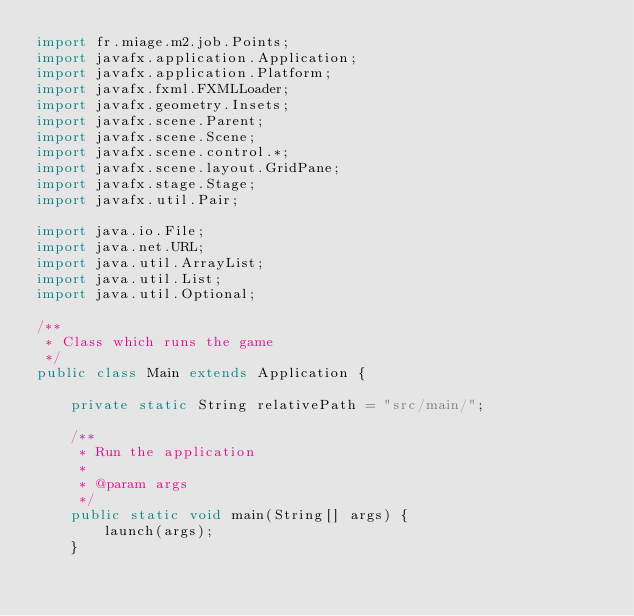<code> <loc_0><loc_0><loc_500><loc_500><_Java_>import fr.miage.m2.job.Points;
import javafx.application.Application;
import javafx.application.Platform;
import javafx.fxml.FXMLLoader;
import javafx.geometry.Insets;
import javafx.scene.Parent;
import javafx.scene.Scene;
import javafx.scene.control.*;
import javafx.scene.layout.GridPane;
import javafx.stage.Stage;
import javafx.util.Pair;

import java.io.File;
import java.net.URL;
import java.util.ArrayList;
import java.util.List;
import java.util.Optional;

/**
 * Class which runs the game
 */
public class Main extends Application {

    private static String relativePath = "src/main/";

    /**
     * Run the application
     *
     * @param args
     */
    public static void main(String[] args) {
        launch(args);
    }
</code> 